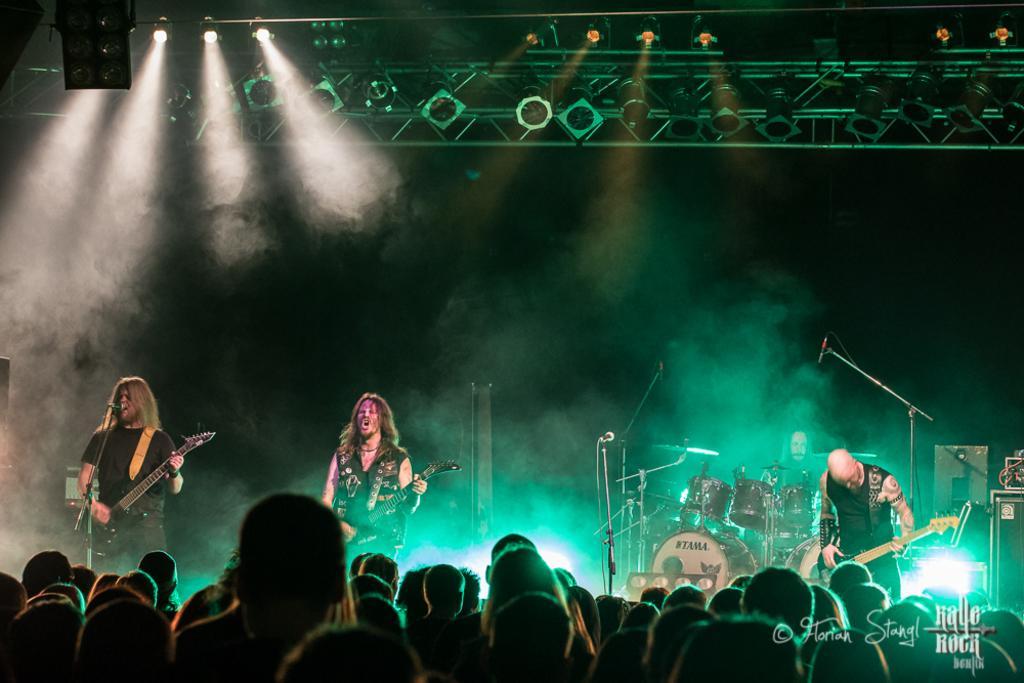How would you summarize this image in a sentence or two? There is a group of people. They are standing on a stage. They are playing a musical instruments,. We can see in background lights and rods. 